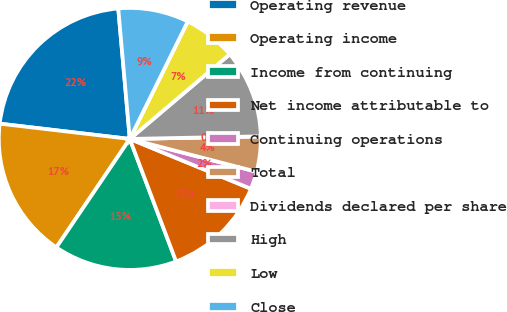Convert chart. <chart><loc_0><loc_0><loc_500><loc_500><pie_chart><fcel>Operating revenue<fcel>Operating income<fcel>Income from continuing<fcel>Net income attributable to<fcel>Continuing operations<fcel>Total<fcel>Dividends declared per share<fcel>High<fcel>Low<fcel>Close<nl><fcel>21.74%<fcel>17.39%<fcel>15.22%<fcel>13.04%<fcel>2.18%<fcel>4.35%<fcel>0.0%<fcel>10.87%<fcel>6.52%<fcel>8.7%<nl></chart> 